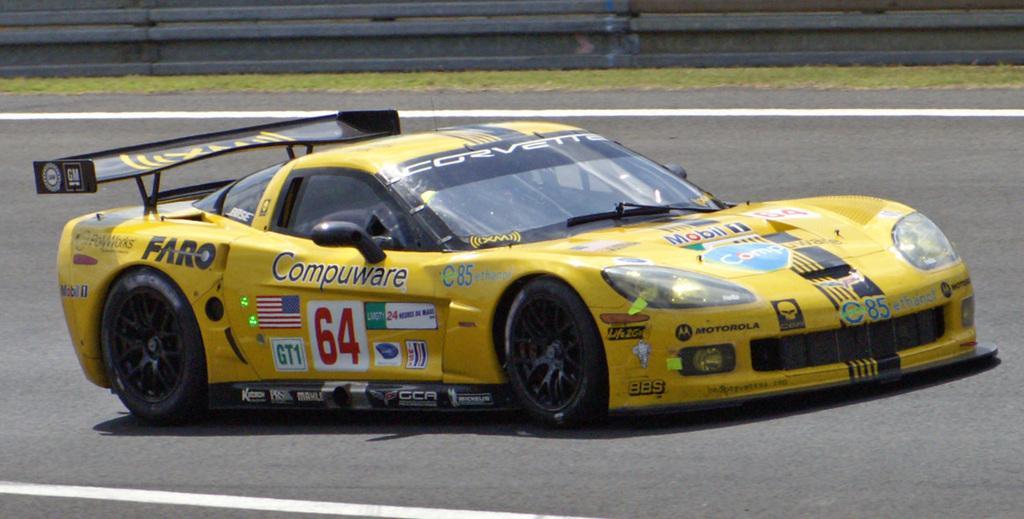Please provide a concise description of this image. In this picture I can see a vehicle on the road. 